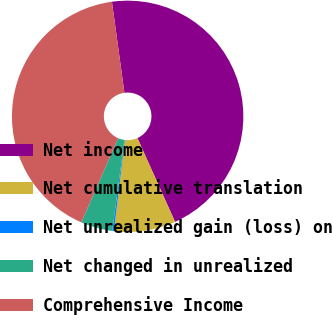Convert chart to OTSL. <chart><loc_0><loc_0><loc_500><loc_500><pie_chart><fcel>Net income<fcel>Net cumulative translation<fcel>Net unrealized gain (loss) on<fcel>Net changed in unrealized<fcel>Comprehensive Income<nl><fcel>45.45%<fcel>8.61%<fcel>0.24%<fcel>4.43%<fcel>41.27%<nl></chart> 